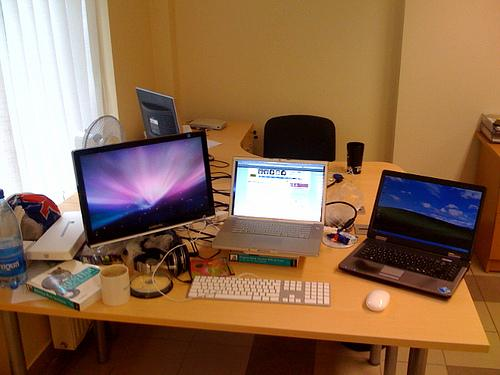What is the white rounded object on the right? Please explain your reasoning. mouse. The object is next to a computer.  it is on a workdesk. 